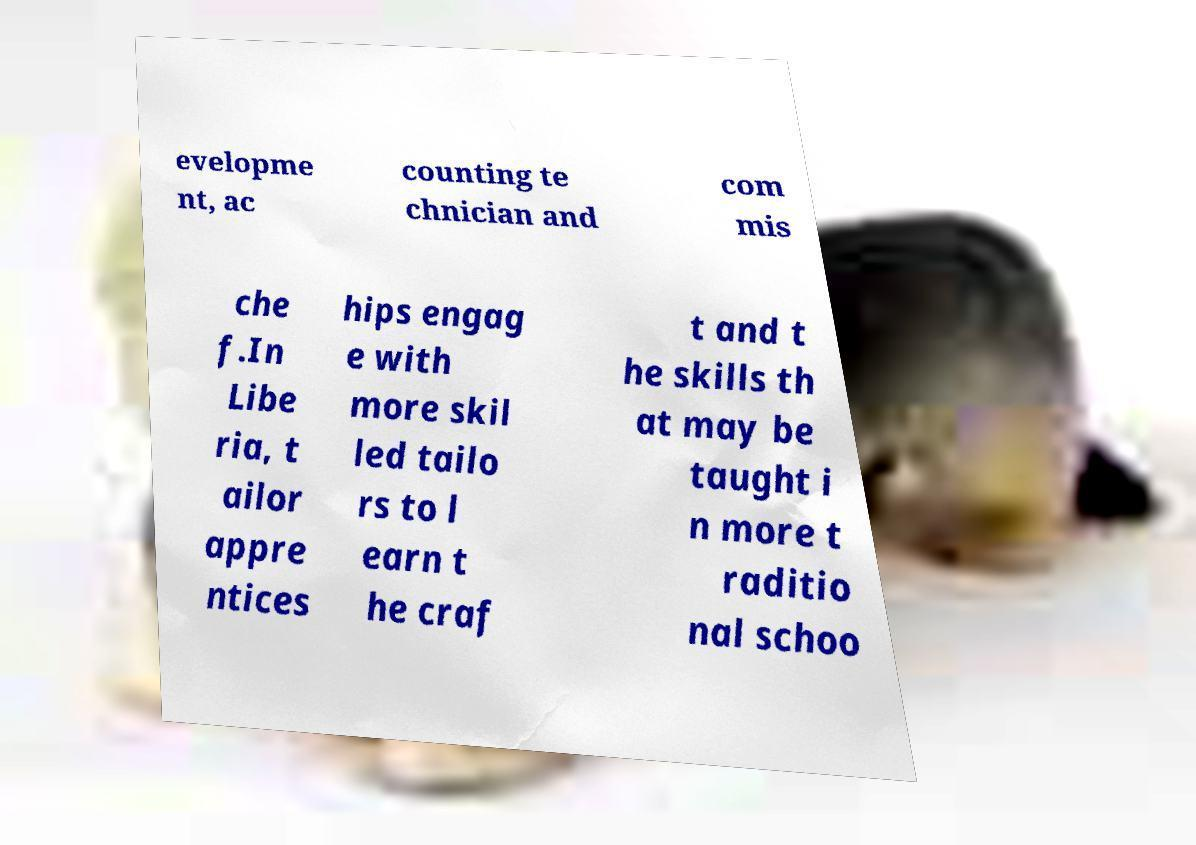For documentation purposes, I need the text within this image transcribed. Could you provide that? evelopme nt, ac counting te chnician and com mis che f.In Libe ria, t ailor appre ntices hips engag e with more skil led tailo rs to l earn t he craf t and t he skills th at may be taught i n more t raditio nal schoo 